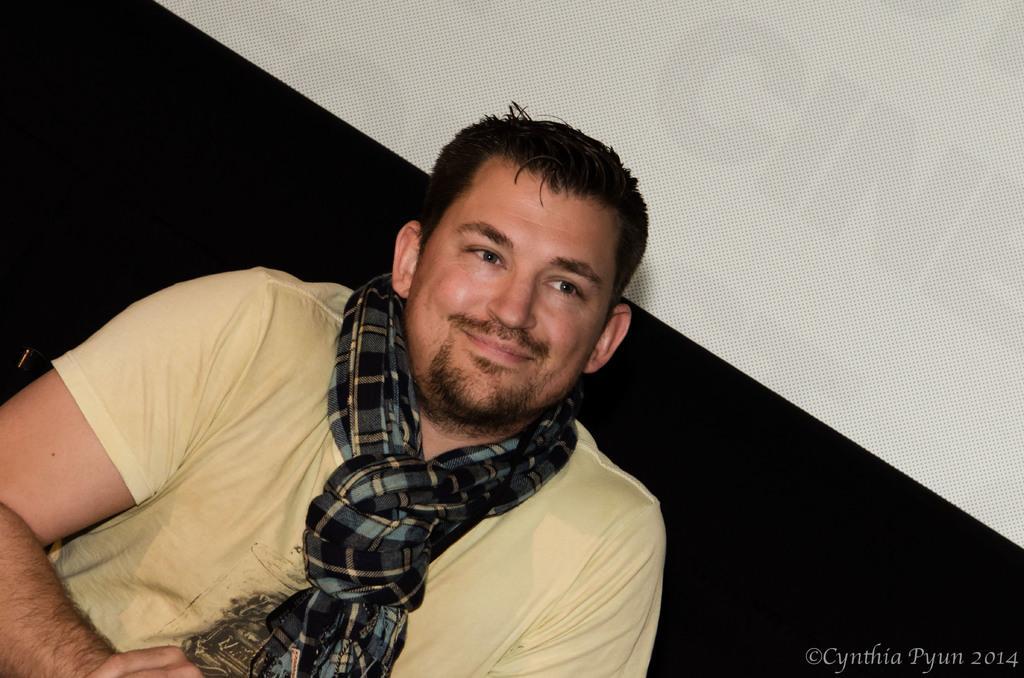How would you summarize this image in a sentence or two? In the center of the image a man is sitting on a couch and wearing scarf and t-shirt. In the background of the image we can see a board. In the bottom right corner we can see some text. 